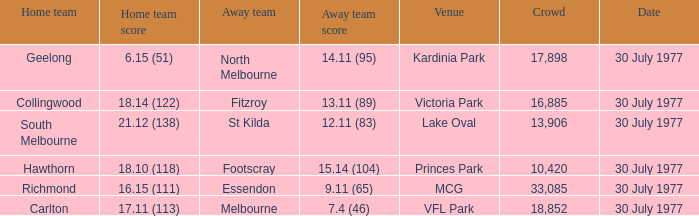Whom is the home team when the away team score is 9.11 (65)? Richmond. 